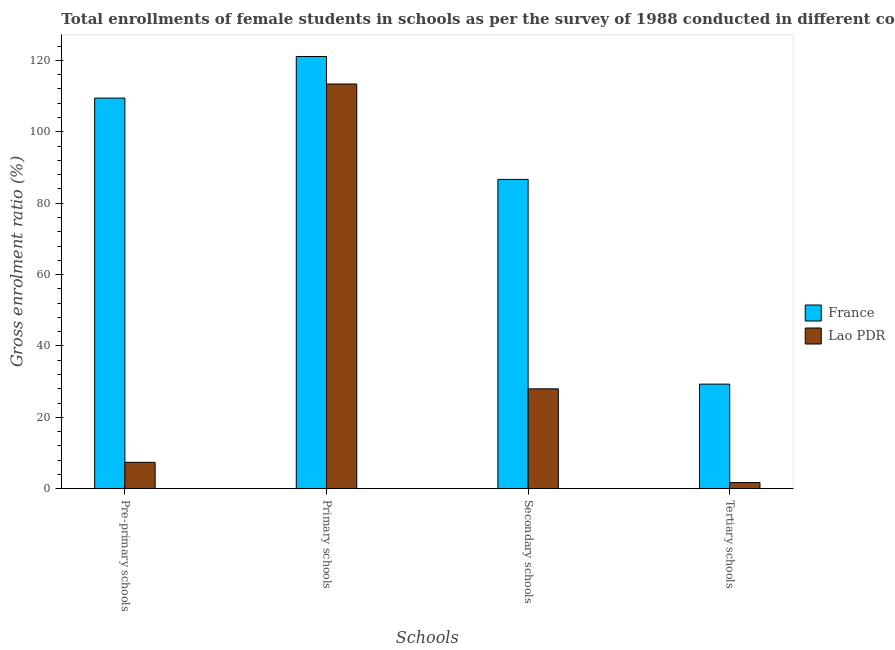How many different coloured bars are there?
Provide a succinct answer. 2. How many bars are there on the 4th tick from the left?
Provide a short and direct response. 2. What is the label of the 2nd group of bars from the left?
Provide a short and direct response. Primary schools. What is the gross enrolment ratio(female) in pre-primary schools in France?
Provide a succinct answer. 109.45. Across all countries, what is the maximum gross enrolment ratio(female) in primary schools?
Give a very brief answer. 121.11. Across all countries, what is the minimum gross enrolment ratio(female) in tertiary schools?
Ensure brevity in your answer.  1.71. In which country was the gross enrolment ratio(female) in tertiary schools maximum?
Offer a very short reply. France. In which country was the gross enrolment ratio(female) in tertiary schools minimum?
Your answer should be compact. Lao PDR. What is the total gross enrolment ratio(female) in pre-primary schools in the graph?
Give a very brief answer. 116.84. What is the difference between the gross enrolment ratio(female) in tertiary schools in France and that in Lao PDR?
Provide a short and direct response. 27.59. What is the difference between the gross enrolment ratio(female) in tertiary schools in France and the gross enrolment ratio(female) in primary schools in Lao PDR?
Your answer should be compact. -84.1. What is the average gross enrolment ratio(female) in primary schools per country?
Ensure brevity in your answer.  117.25. What is the difference between the gross enrolment ratio(female) in secondary schools and gross enrolment ratio(female) in primary schools in France?
Give a very brief answer. -34.44. What is the ratio of the gross enrolment ratio(female) in tertiary schools in Lao PDR to that in France?
Give a very brief answer. 0.06. Is the difference between the gross enrolment ratio(female) in primary schools in Lao PDR and France greater than the difference between the gross enrolment ratio(female) in pre-primary schools in Lao PDR and France?
Provide a succinct answer. Yes. What is the difference between the highest and the second highest gross enrolment ratio(female) in secondary schools?
Your response must be concise. 58.69. What is the difference between the highest and the lowest gross enrolment ratio(female) in tertiary schools?
Keep it short and to the point. 27.59. In how many countries, is the gross enrolment ratio(female) in pre-primary schools greater than the average gross enrolment ratio(female) in pre-primary schools taken over all countries?
Your answer should be compact. 1. Is it the case that in every country, the sum of the gross enrolment ratio(female) in tertiary schools and gross enrolment ratio(female) in primary schools is greater than the sum of gross enrolment ratio(female) in pre-primary schools and gross enrolment ratio(female) in secondary schools?
Your response must be concise. No. What does the 1st bar from the left in Primary schools represents?
Give a very brief answer. France. What does the 2nd bar from the right in Secondary schools represents?
Give a very brief answer. France. How many bars are there?
Keep it short and to the point. 8. How many countries are there in the graph?
Your answer should be compact. 2. What is the difference between two consecutive major ticks on the Y-axis?
Provide a short and direct response. 20. Are the values on the major ticks of Y-axis written in scientific E-notation?
Provide a short and direct response. No. How many legend labels are there?
Your response must be concise. 2. How are the legend labels stacked?
Your response must be concise. Vertical. What is the title of the graph?
Keep it short and to the point. Total enrollments of female students in schools as per the survey of 1988 conducted in different countries. What is the label or title of the X-axis?
Keep it short and to the point. Schools. What is the Gross enrolment ratio (%) in France in Pre-primary schools?
Provide a succinct answer. 109.45. What is the Gross enrolment ratio (%) in Lao PDR in Pre-primary schools?
Keep it short and to the point. 7.39. What is the Gross enrolment ratio (%) in France in Primary schools?
Keep it short and to the point. 121.11. What is the Gross enrolment ratio (%) in Lao PDR in Primary schools?
Provide a short and direct response. 113.4. What is the Gross enrolment ratio (%) of France in Secondary schools?
Keep it short and to the point. 86.67. What is the Gross enrolment ratio (%) in Lao PDR in Secondary schools?
Provide a succinct answer. 27.98. What is the Gross enrolment ratio (%) of France in Tertiary schools?
Provide a succinct answer. 29.29. What is the Gross enrolment ratio (%) in Lao PDR in Tertiary schools?
Give a very brief answer. 1.71. Across all Schools, what is the maximum Gross enrolment ratio (%) in France?
Keep it short and to the point. 121.11. Across all Schools, what is the maximum Gross enrolment ratio (%) in Lao PDR?
Offer a very short reply. 113.4. Across all Schools, what is the minimum Gross enrolment ratio (%) in France?
Your answer should be very brief. 29.29. Across all Schools, what is the minimum Gross enrolment ratio (%) in Lao PDR?
Make the answer very short. 1.71. What is the total Gross enrolment ratio (%) in France in the graph?
Ensure brevity in your answer.  346.52. What is the total Gross enrolment ratio (%) of Lao PDR in the graph?
Give a very brief answer. 150.47. What is the difference between the Gross enrolment ratio (%) of France in Pre-primary schools and that in Primary schools?
Your response must be concise. -11.66. What is the difference between the Gross enrolment ratio (%) in Lao PDR in Pre-primary schools and that in Primary schools?
Provide a succinct answer. -106.01. What is the difference between the Gross enrolment ratio (%) in France in Pre-primary schools and that in Secondary schools?
Make the answer very short. 22.78. What is the difference between the Gross enrolment ratio (%) in Lao PDR in Pre-primary schools and that in Secondary schools?
Your answer should be compact. -20.59. What is the difference between the Gross enrolment ratio (%) of France in Pre-primary schools and that in Tertiary schools?
Make the answer very short. 80.16. What is the difference between the Gross enrolment ratio (%) of Lao PDR in Pre-primary schools and that in Tertiary schools?
Give a very brief answer. 5.68. What is the difference between the Gross enrolment ratio (%) of France in Primary schools and that in Secondary schools?
Offer a terse response. 34.44. What is the difference between the Gross enrolment ratio (%) of Lao PDR in Primary schools and that in Secondary schools?
Offer a terse response. 85.42. What is the difference between the Gross enrolment ratio (%) in France in Primary schools and that in Tertiary schools?
Offer a very short reply. 91.82. What is the difference between the Gross enrolment ratio (%) in Lao PDR in Primary schools and that in Tertiary schools?
Your answer should be very brief. 111.69. What is the difference between the Gross enrolment ratio (%) of France in Secondary schools and that in Tertiary schools?
Provide a short and direct response. 57.37. What is the difference between the Gross enrolment ratio (%) of Lao PDR in Secondary schools and that in Tertiary schools?
Ensure brevity in your answer.  26.27. What is the difference between the Gross enrolment ratio (%) in France in Pre-primary schools and the Gross enrolment ratio (%) in Lao PDR in Primary schools?
Keep it short and to the point. -3.95. What is the difference between the Gross enrolment ratio (%) of France in Pre-primary schools and the Gross enrolment ratio (%) of Lao PDR in Secondary schools?
Provide a succinct answer. 81.47. What is the difference between the Gross enrolment ratio (%) of France in Pre-primary schools and the Gross enrolment ratio (%) of Lao PDR in Tertiary schools?
Provide a short and direct response. 107.75. What is the difference between the Gross enrolment ratio (%) in France in Primary schools and the Gross enrolment ratio (%) in Lao PDR in Secondary schools?
Make the answer very short. 93.13. What is the difference between the Gross enrolment ratio (%) in France in Primary schools and the Gross enrolment ratio (%) in Lao PDR in Tertiary schools?
Your response must be concise. 119.4. What is the difference between the Gross enrolment ratio (%) in France in Secondary schools and the Gross enrolment ratio (%) in Lao PDR in Tertiary schools?
Provide a short and direct response. 84.96. What is the average Gross enrolment ratio (%) of France per Schools?
Your response must be concise. 86.63. What is the average Gross enrolment ratio (%) in Lao PDR per Schools?
Your answer should be compact. 37.62. What is the difference between the Gross enrolment ratio (%) of France and Gross enrolment ratio (%) of Lao PDR in Pre-primary schools?
Your answer should be very brief. 102.07. What is the difference between the Gross enrolment ratio (%) in France and Gross enrolment ratio (%) in Lao PDR in Primary schools?
Your answer should be very brief. 7.71. What is the difference between the Gross enrolment ratio (%) of France and Gross enrolment ratio (%) of Lao PDR in Secondary schools?
Provide a short and direct response. 58.69. What is the difference between the Gross enrolment ratio (%) of France and Gross enrolment ratio (%) of Lao PDR in Tertiary schools?
Give a very brief answer. 27.59. What is the ratio of the Gross enrolment ratio (%) of France in Pre-primary schools to that in Primary schools?
Give a very brief answer. 0.9. What is the ratio of the Gross enrolment ratio (%) of Lao PDR in Pre-primary schools to that in Primary schools?
Offer a terse response. 0.07. What is the ratio of the Gross enrolment ratio (%) in France in Pre-primary schools to that in Secondary schools?
Keep it short and to the point. 1.26. What is the ratio of the Gross enrolment ratio (%) of Lao PDR in Pre-primary schools to that in Secondary schools?
Your answer should be very brief. 0.26. What is the ratio of the Gross enrolment ratio (%) in France in Pre-primary schools to that in Tertiary schools?
Keep it short and to the point. 3.74. What is the ratio of the Gross enrolment ratio (%) of Lao PDR in Pre-primary schools to that in Tertiary schools?
Make the answer very short. 4.33. What is the ratio of the Gross enrolment ratio (%) of France in Primary schools to that in Secondary schools?
Your response must be concise. 1.4. What is the ratio of the Gross enrolment ratio (%) of Lao PDR in Primary schools to that in Secondary schools?
Provide a short and direct response. 4.05. What is the ratio of the Gross enrolment ratio (%) in France in Primary schools to that in Tertiary schools?
Give a very brief answer. 4.13. What is the ratio of the Gross enrolment ratio (%) in Lao PDR in Primary schools to that in Tertiary schools?
Provide a short and direct response. 66.49. What is the ratio of the Gross enrolment ratio (%) in France in Secondary schools to that in Tertiary schools?
Your response must be concise. 2.96. What is the ratio of the Gross enrolment ratio (%) of Lao PDR in Secondary schools to that in Tertiary schools?
Offer a terse response. 16.41. What is the difference between the highest and the second highest Gross enrolment ratio (%) in France?
Make the answer very short. 11.66. What is the difference between the highest and the second highest Gross enrolment ratio (%) of Lao PDR?
Your answer should be very brief. 85.42. What is the difference between the highest and the lowest Gross enrolment ratio (%) in France?
Your answer should be very brief. 91.82. What is the difference between the highest and the lowest Gross enrolment ratio (%) in Lao PDR?
Offer a terse response. 111.69. 